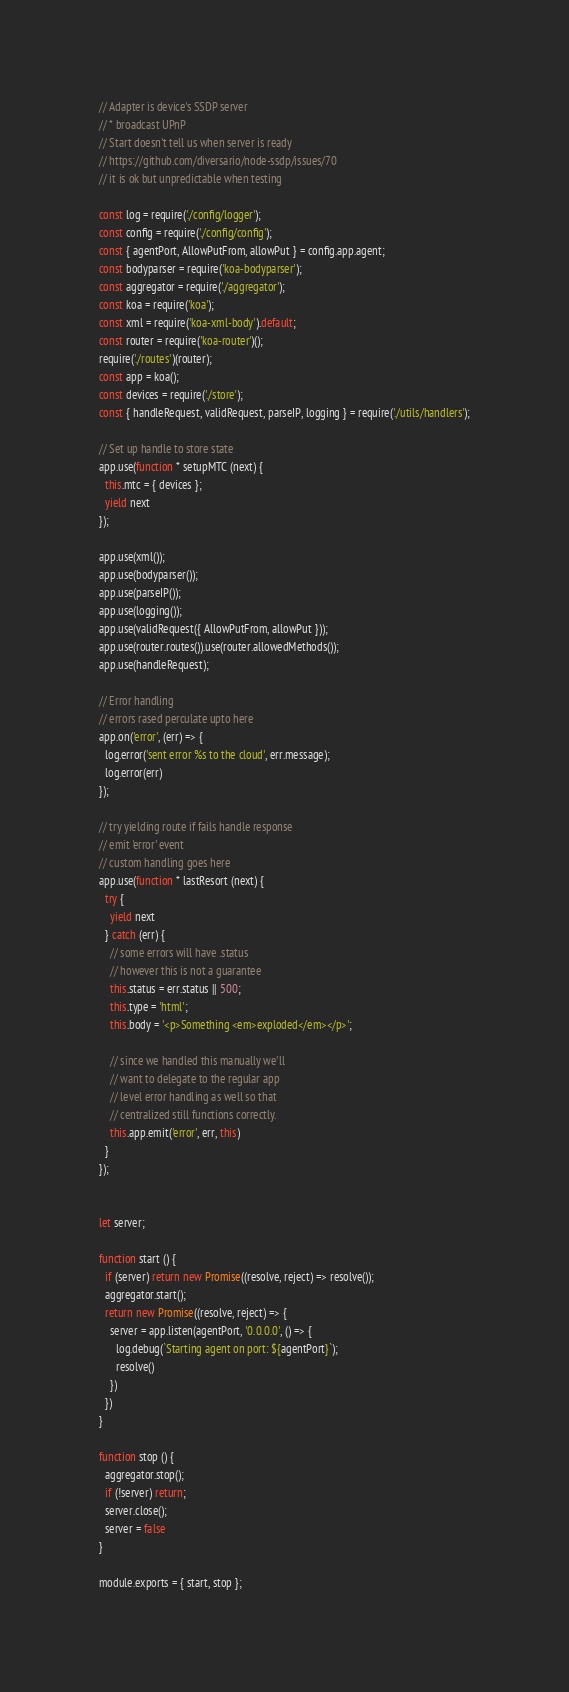<code> <loc_0><loc_0><loc_500><loc_500><_JavaScript_>// Adapter is device's SSDP server
// * broadcast UPnP
// Start doesn't tell us when server is ready
// https://github.com/diversario/node-ssdp/issues/70
// it is ok but unpredictable when testing

const log = require('./config/logger');
const config = require('./config/config');
const { agentPort, AllowPutFrom, allowPut } = config.app.agent;
const bodyparser = require('koa-bodyparser');
const aggregator = require('./aggregator');
const koa = require('koa');
const xml = require('koa-xml-body').default;
const router = require('koa-router')();
require('./routes')(router);
const app = koa();
const devices = require('./store');
const { handleRequest, validRequest, parseIP, logging } = require('./utils/handlers');

// Set up handle to store state
app.use(function * setupMTC (next) {
  this.mtc = { devices };
  yield next
});

app.use(xml());
app.use(bodyparser());
app.use(parseIP());
app.use(logging());
app.use(validRequest({ AllowPutFrom, allowPut }));
app.use(router.routes()).use(router.allowedMethods());
app.use(handleRequest);

// Error handling
// errors rased perculate upto here
app.on('error', (err) => {
  log.error('sent error %s to the cloud', err.message);
  log.error(err)
});

// try yielding route if fails handle response
// emit 'error' event
// custom handling goes here
app.use(function * lastResort (next) {
  try {
    yield next
  } catch (err) {
    // some errors will have .status
    // however this is not a guarantee
    this.status = err.status || 500;
    this.type = 'html';
    this.body = '<p>Something <em>exploded</em></p>';

    // since we handled this manually we'll
    // want to delegate to the regular app
    // level error handling as well so that
    // centralized still functions correctly.
    this.app.emit('error', err, this)
  }
});


let server;

function start () {
  if (server) return new Promise((resolve, reject) => resolve());
  aggregator.start();
  return new Promise((resolve, reject) => {
    server = app.listen(agentPort, '0.0.0.0', () => {
      log.debug(`Starting agent on port: ${agentPort}`);
      resolve()
    })
  })
}

function stop () {
  aggregator.stop();
  if (!server) return;
  server.close();
  server = false
}

module.exports = { start, stop };

</code> 